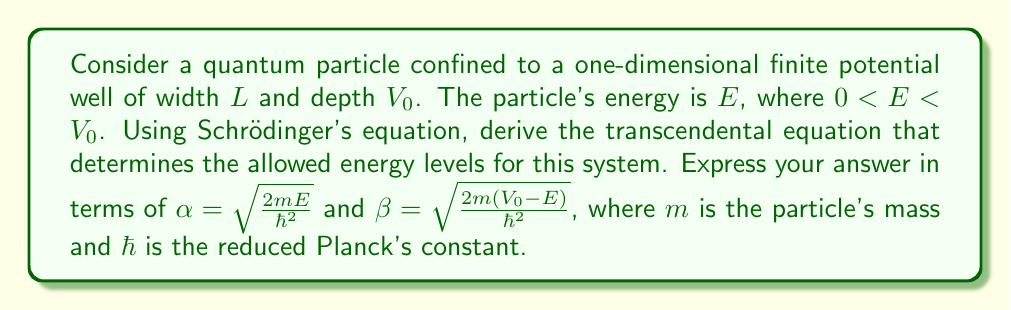Give your solution to this math problem. Let's approach this step-by-step:

1) The time-independent Schrödinger equation in one dimension is:

   $$-\frac{\hbar^2}{2m}\frac{d^2\psi}{dx^2} + V(x)\psi = E\psi$$

2) For a finite potential well, we have:
   
   $V(x) = \begin{cases} 
   0, & 0 < x < L \\
   V_0, & \text{otherwise}
   \end{cases}$

3) We need to solve the equation in three regions:
   
   Region I (x < 0): $\frac{d^2\psi_I}{dx^2} = \beta^2\psi_I$
   
   Region II (0 < x < L): $\frac{d^2\psi_{II}}{dx^2} = -\alpha^2\psi_{II}$
   
   Region III (x > L): $\frac{d^2\psi_{III}}{dx^2} = \beta^2\psi_{III}$

4) The general solutions are:
   
   $\psi_I = Ae^{\beta x}$
   
   $\psi_{II} = B\sin(\alpha x) + C\cos(\alpha x)$
   
   $\psi_{III} = De^{-\beta x}$

5) We apply boundary conditions:
   
   a) $\psi_I(0) = \psi_{II}(0)$
   
   b) $\psi_{II}(L) = \psi_{III}(L)$
   
   c) $\frac{d\psi_I}{dx}(0) = \frac{d\psi_{II}}{dx}(0)$
   
   d) $\frac{d\psi_{II}}{dx}(L) = \frac{d\psi_{III}}{dx}(L)$

6) From these conditions, we get:
   
   $A = C$
   
   $B\sin(\alpha L) + C\cos(\alpha L) = De^{-\beta L}$
   
   $\beta A = \alpha B$
   
   $\alpha B\cos(\alpha L) - \alpha C\sin(\alpha L) = -\beta De^{-\beta L}$

7) Dividing the last equation by the second equation:

   $\alpha\frac{B\cos(\alpha L) - C\sin(\alpha L)}{B\sin(\alpha L) + C\cos(\alpha L)} = -\beta$

8) Using $\tan(\alpha L) = \frac{\sin(\alpha L)}{\cos(\alpha L)}$ and $\frac{B}{C} = \frac{\beta}{\alpha}$ from step 6:

   $\alpha\frac{\frac{\beta}{\alpha} - \tan(\alpha L)}{1 + \frac{\beta}{\alpha}\tan(\alpha L)} = -\beta$

9) Simplifying:

   $\frac{\beta - \alpha\tan(\alpha L)}{\alpha + \beta\tan(\alpha L)} = -\frac{\beta}{\alpha}$

10) Cross-multiplying and simplifying leads to the transcendental equation:

    $\alpha\tan(\alpha L) = \beta$

This equation determines the allowed energy levels for the particle in the finite potential well.
Answer: $\alpha\tan(\alpha L) = \beta$ 